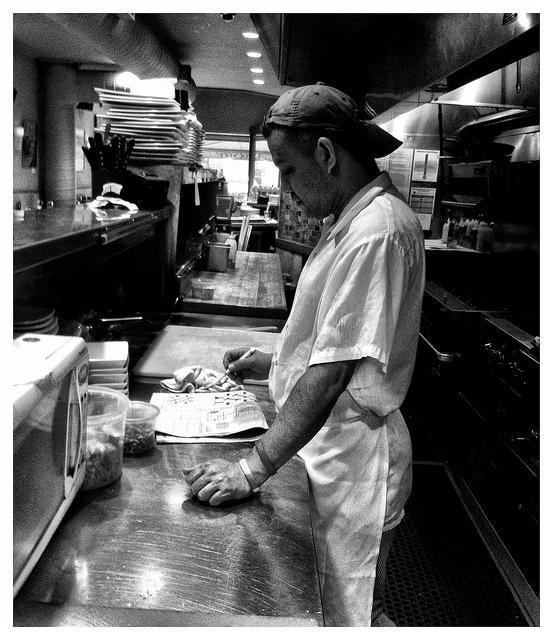How many armbands is the man wearing?
Give a very brief answer. 2. How many birds are on the branch?
Give a very brief answer. 0. 